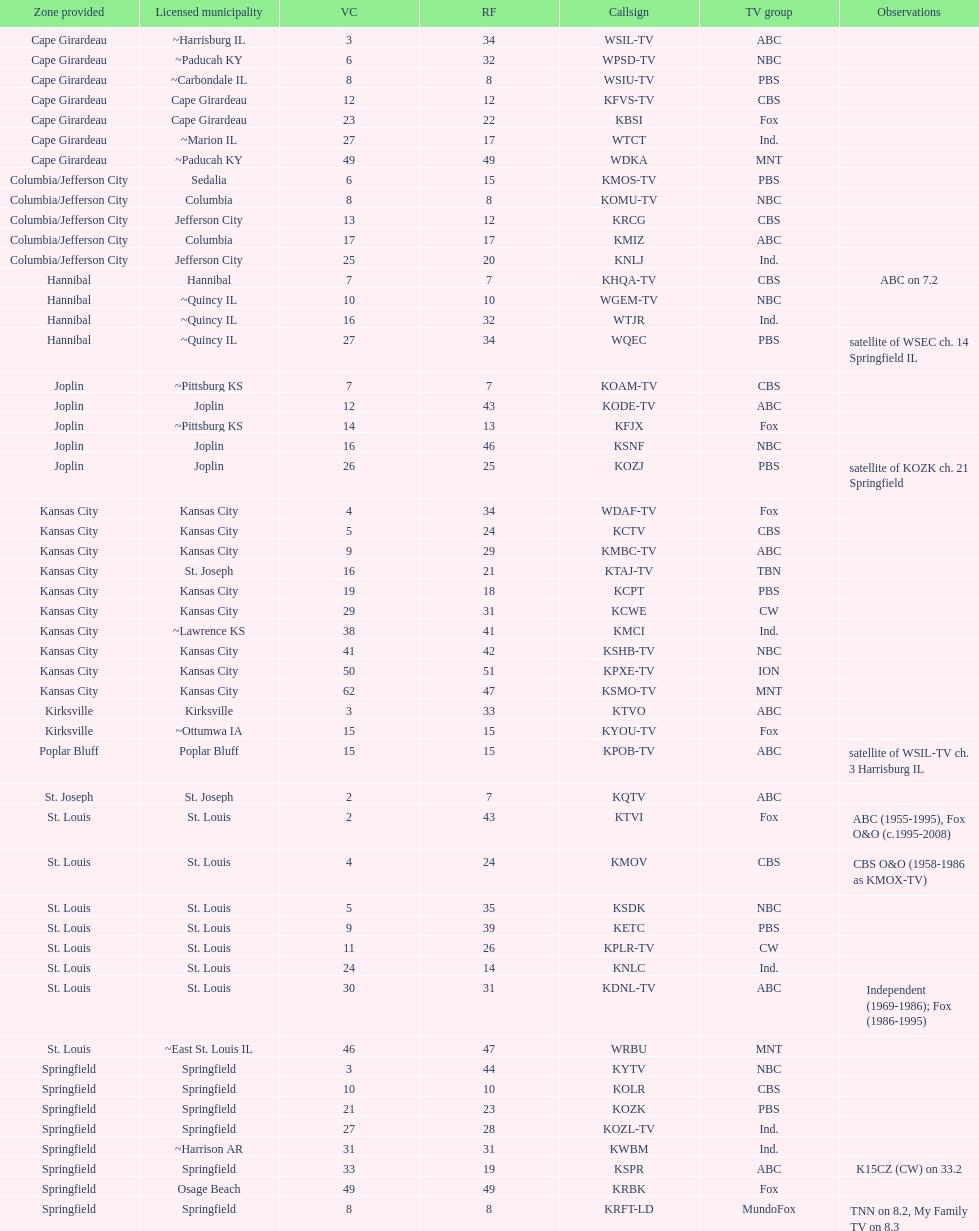Which station possesses a license in the same city as koam-tv? KFJX. 